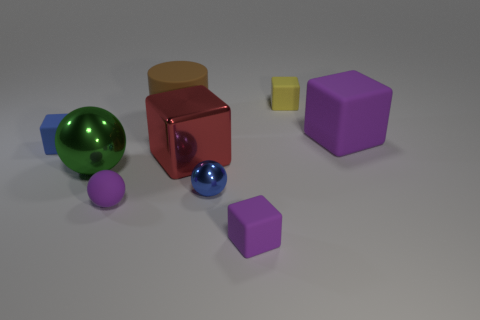What material is the large cube that is the same color as the rubber ball?
Give a very brief answer. Rubber. The thing that is the same color as the tiny metal sphere is what shape?
Ensure brevity in your answer.  Cube. How many objects are in front of the yellow thing and on the left side of the large purple rubber object?
Your answer should be very brief. 7. What is the yellow object made of?
Make the answer very short. Rubber. What shape is the green object that is the same size as the brown cylinder?
Provide a short and direct response. Sphere. Is the material of the large cube that is on the right side of the small purple block the same as the small cube that is to the left of the large brown cylinder?
Keep it short and to the point. Yes. How many blue shiny spheres are there?
Your response must be concise. 1. What number of tiny blue metallic objects have the same shape as the tiny yellow thing?
Your answer should be compact. 0. Is the yellow rubber object the same shape as the large green shiny thing?
Offer a very short reply. No. What size is the brown cylinder?
Offer a terse response. Large. 